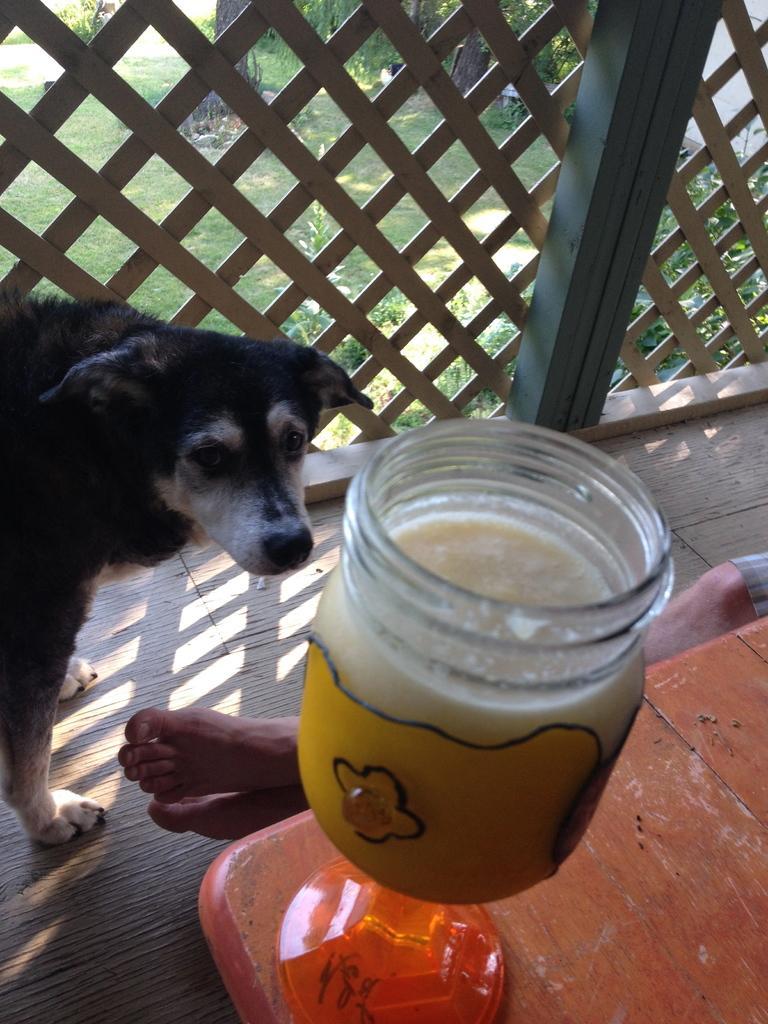Describe this image in one or two sentences. At the bottom of this image, I can see a table on which a bottle is placed. Beside this table I can see a person's legs. On the left side there is a black color dog which is looking at this bottle. On the top of the image I can see the fencing, at the back of it I can see the grass, plants and trees. 